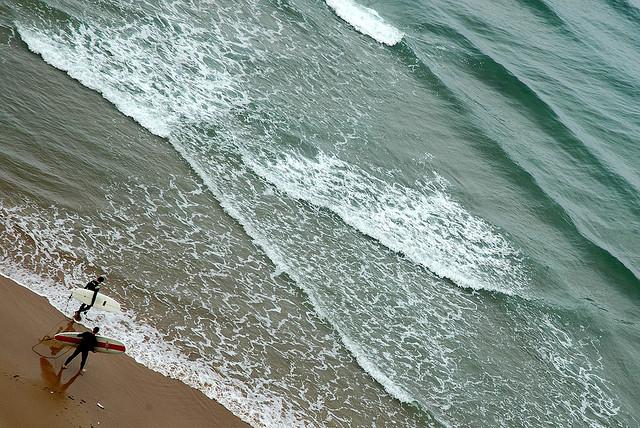What type of water is this?
Keep it brief. Ocean. How many people are going surfing?
Keep it brief. 2. How many waves are near the shore?
Keep it brief. 4. 